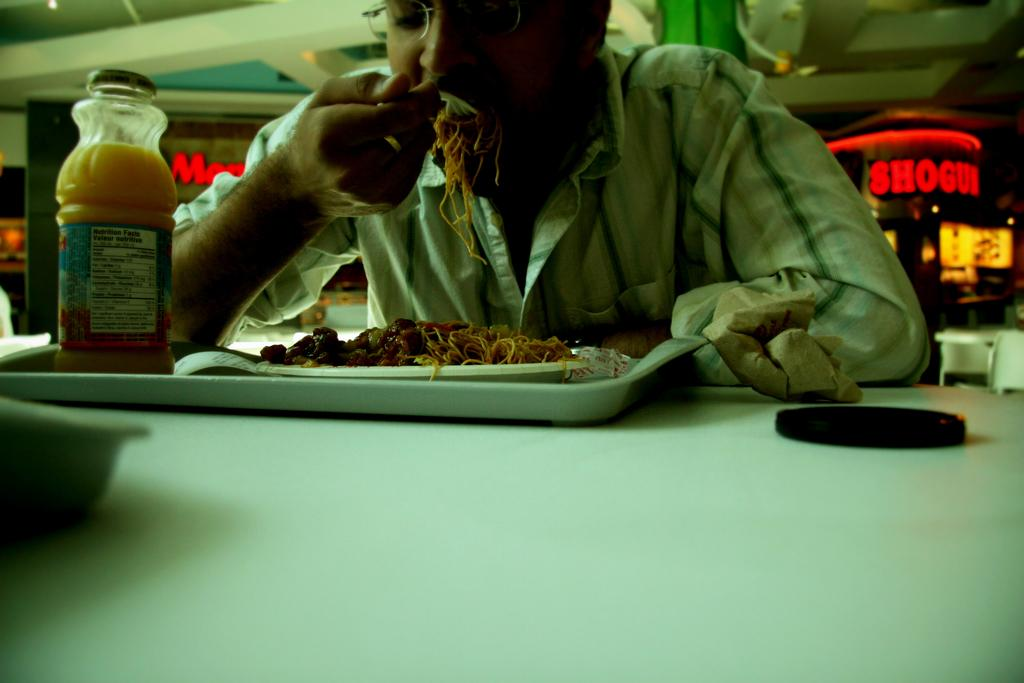<image>
Present a compact description of the photo's key features. The bottle of orange juice has 135 calories. 